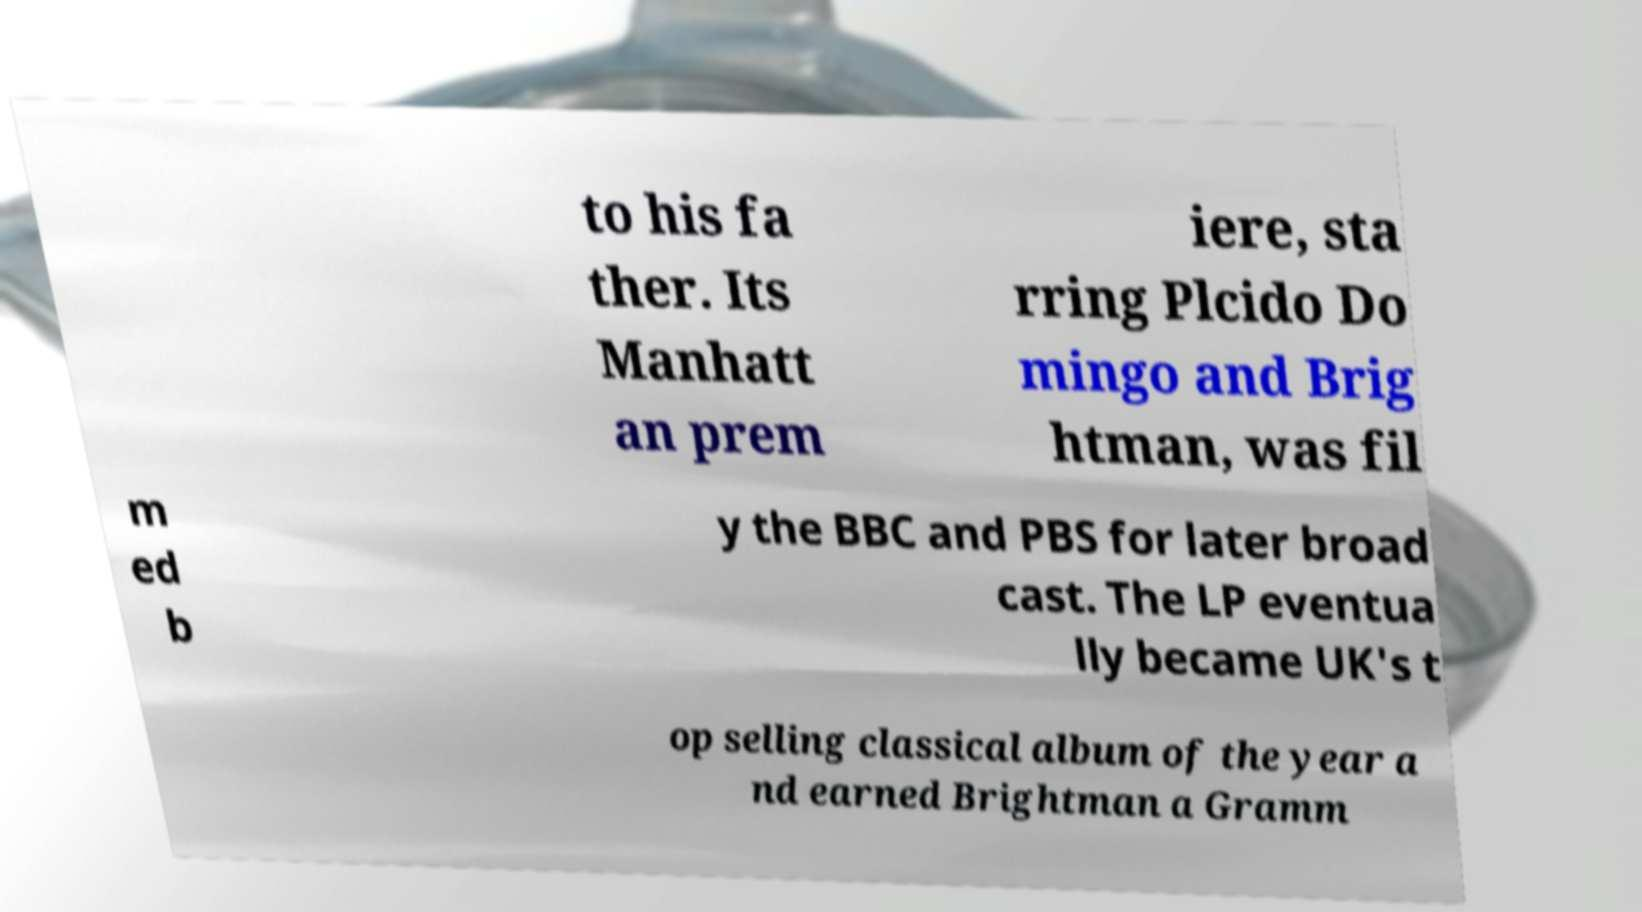Please identify and transcribe the text found in this image. to his fa ther. Its Manhatt an prem iere, sta rring Plcido Do mingo and Brig htman, was fil m ed b y the BBC and PBS for later broad cast. The LP eventua lly became UK's t op selling classical album of the year a nd earned Brightman a Gramm 